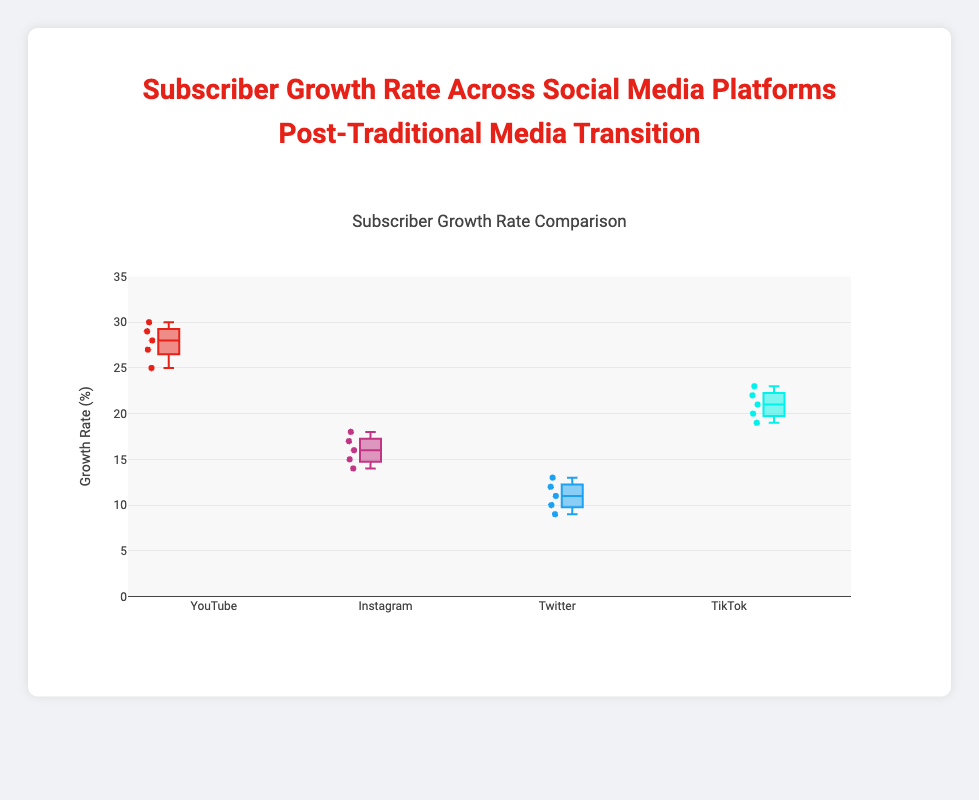Which platform shows the highest median growth rate? Look at the median line in each box plot; the highest median line is for YouTube.
Answer: YouTube What is the range of growth rates for Instagram? Identify the lowest and highest points in the Instagram box plot; these are 14 and 18, and their difference is 4.
Answer: 4 How does the median growth rate of TikTok compare to Twitter? Check the median lines of both TikTok and Twitter; TikTok's is higher than Twitter's.
Answer: TikTok is higher Which social media platform has the most spread in growth rates? Compare the length of the boxes for all platforms; TikTok has the widest spread.
Answer: TikTok Does YouTube have any outliers in its growth rate data? Check for any points outside the whiskers of the YouTube box plot; YouTube has no data points outside the whiskers, so no outliers exist.
Answer: No What is the third quartile value for Twitter's growth rate? The third quartile is the upper edge of the box for Twitter; it is around 13.
Answer: 13 Compare the interquartile range (IQR) of YouTube and Instagram. Which has a larger IQR? Calculate the IQR (upper quartile minus lower quartile) for both YouTube and Instagram; YouTube's IQR is larger.
Answer: YouTube Which platform has the lowest minimum growth rate? Look at the lowest point in each box plot; Twitter has the lowest minimum growth rate at 9%.
Answer: Twitter What are the growth rate outliers, if any, for TikTok? Check for any points outside the whiskers of TikTok's box plot; TikTok has no outliers.
Answer: None What is the second quartile (median) value for Instagram's growth rate? The second quartile is the median, which is the line inside the box for Instagram; it is around 16.
Answer: 16 